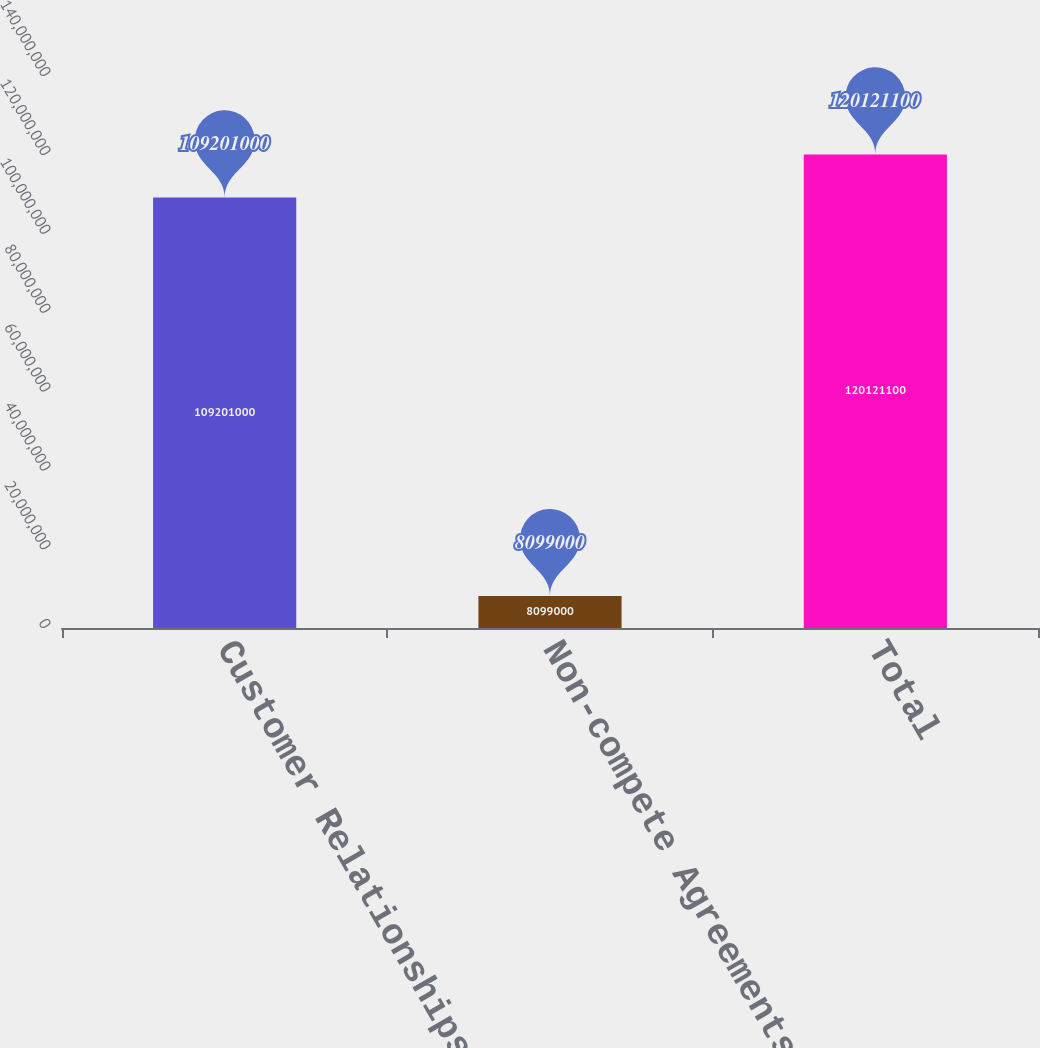Convert chart to OTSL. <chart><loc_0><loc_0><loc_500><loc_500><bar_chart><fcel>Customer Relationships<fcel>Non-compete Agreements<fcel>Total<nl><fcel>1.09201e+08<fcel>8.099e+06<fcel>1.20121e+08<nl></chart> 